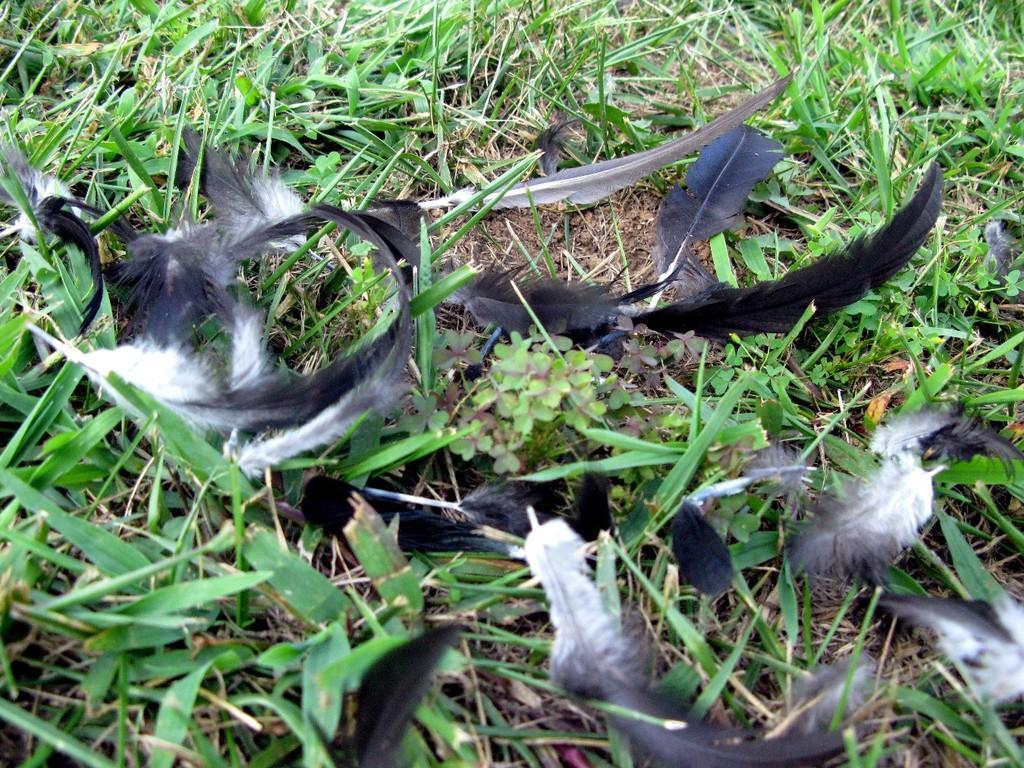Please provide a concise description of this image. The picture consists of feathers, plants, grass and soil. 